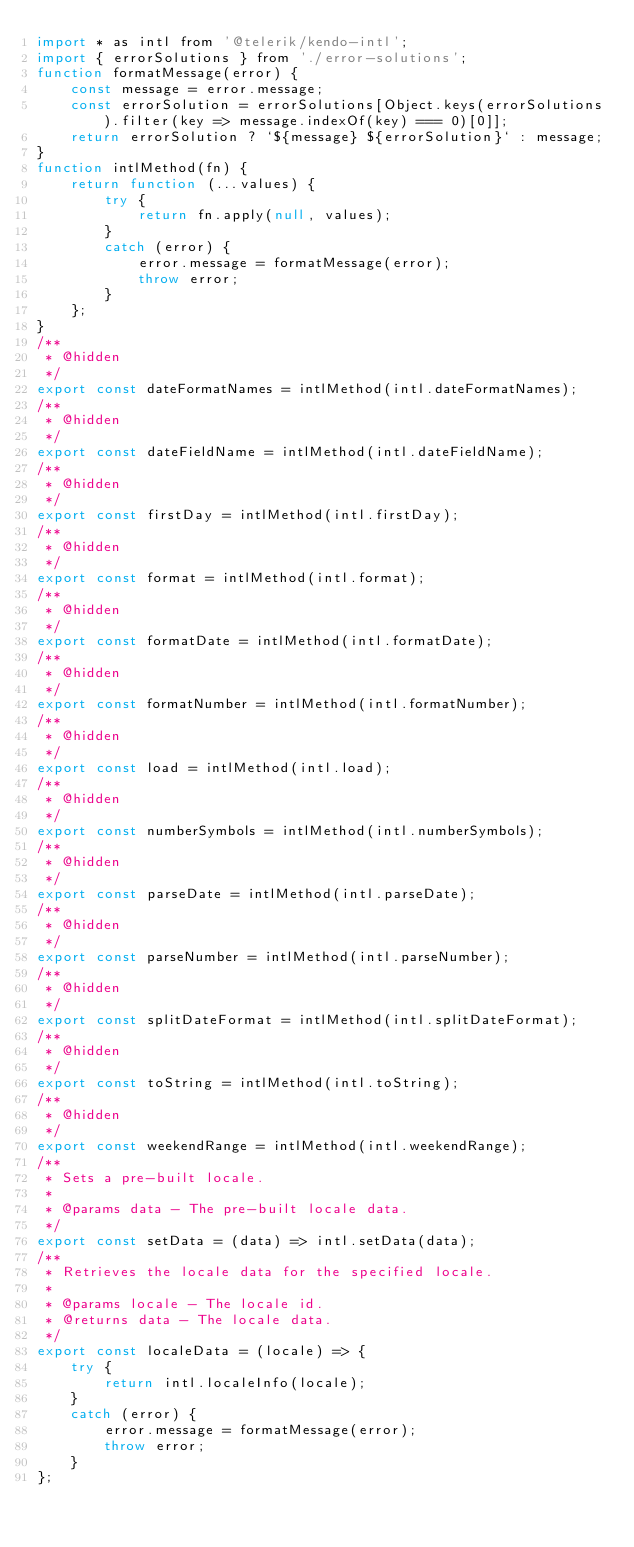<code> <loc_0><loc_0><loc_500><loc_500><_JavaScript_>import * as intl from '@telerik/kendo-intl';
import { errorSolutions } from './error-solutions';
function formatMessage(error) {
    const message = error.message;
    const errorSolution = errorSolutions[Object.keys(errorSolutions).filter(key => message.indexOf(key) === 0)[0]];
    return errorSolution ? `${message} ${errorSolution}` : message;
}
function intlMethod(fn) {
    return function (...values) {
        try {
            return fn.apply(null, values);
        }
        catch (error) {
            error.message = formatMessage(error);
            throw error;
        }
    };
}
/**
 * @hidden
 */
export const dateFormatNames = intlMethod(intl.dateFormatNames);
/**
 * @hidden
 */
export const dateFieldName = intlMethod(intl.dateFieldName);
/**
 * @hidden
 */
export const firstDay = intlMethod(intl.firstDay);
/**
 * @hidden
 */
export const format = intlMethod(intl.format);
/**
 * @hidden
 */
export const formatDate = intlMethod(intl.formatDate);
/**
 * @hidden
 */
export const formatNumber = intlMethod(intl.formatNumber);
/**
 * @hidden
 */
export const load = intlMethod(intl.load);
/**
 * @hidden
 */
export const numberSymbols = intlMethod(intl.numberSymbols);
/**
 * @hidden
 */
export const parseDate = intlMethod(intl.parseDate);
/**
 * @hidden
 */
export const parseNumber = intlMethod(intl.parseNumber);
/**
 * @hidden
 */
export const splitDateFormat = intlMethod(intl.splitDateFormat);
/**
 * @hidden
 */
export const toString = intlMethod(intl.toString);
/**
 * @hidden
 */
export const weekendRange = intlMethod(intl.weekendRange);
/**
 * Sets a pre-built locale.
 *
 * @params data - The pre-built locale data.
 */
export const setData = (data) => intl.setData(data);
/**
 * Retrieves the locale data for the specified locale.
 *
 * @params locale - The locale id.
 * @returns data - The locale data.
 */
export const localeData = (locale) => {
    try {
        return intl.localeInfo(locale);
    }
    catch (error) {
        error.message = formatMessage(error);
        throw error;
    }
};
</code> 